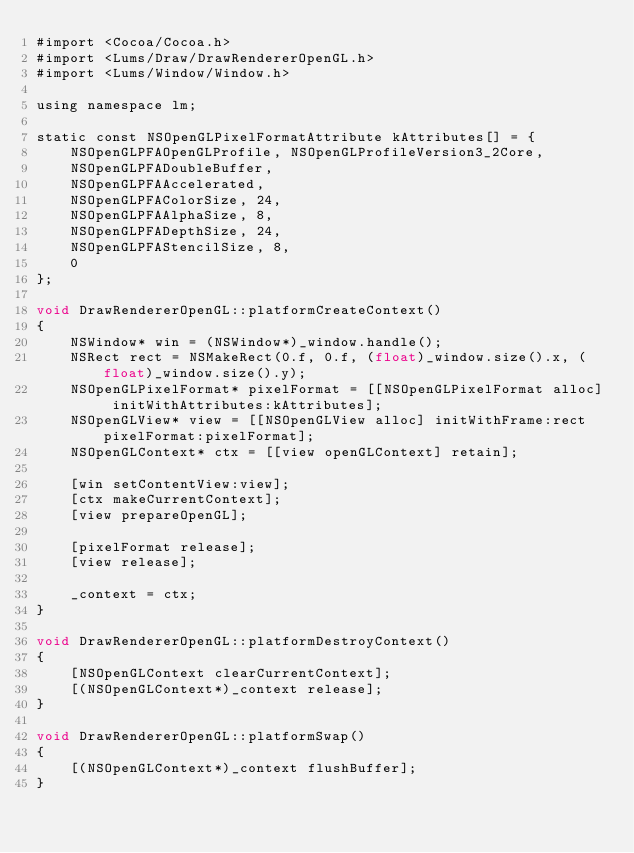<code> <loc_0><loc_0><loc_500><loc_500><_ObjectiveC_>#import <Cocoa/Cocoa.h>
#import <Lums/Draw/DrawRendererOpenGL.h>
#import <Lums/Window/Window.h>

using namespace lm;

static const NSOpenGLPixelFormatAttribute kAttributes[] = {
    NSOpenGLPFAOpenGLProfile, NSOpenGLProfileVersion3_2Core,
    NSOpenGLPFADoubleBuffer,
    NSOpenGLPFAAccelerated,
    NSOpenGLPFAColorSize, 24,
    NSOpenGLPFAAlphaSize, 8,
    NSOpenGLPFADepthSize, 24,
    NSOpenGLPFAStencilSize, 8,
    0
};

void DrawRendererOpenGL::platformCreateContext()
{
    NSWindow* win = (NSWindow*)_window.handle();
    NSRect rect = NSMakeRect(0.f, 0.f, (float)_window.size().x, (float)_window.size().y);
    NSOpenGLPixelFormat* pixelFormat = [[NSOpenGLPixelFormat alloc] initWithAttributes:kAttributes];
    NSOpenGLView* view = [[NSOpenGLView alloc] initWithFrame:rect pixelFormat:pixelFormat];
    NSOpenGLContext* ctx = [[view openGLContext] retain];

    [win setContentView:view];
    [ctx makeCurrentContext];
    [view prepareOpenGL];

    [pixelFormat release];
    [view release];

    _context = ctx;
}

void DrawRendererOpenGL::platformDestroyContext()
{
    [NSOpenGLContext clearCurrentContext];
    [(NSOpenGLContext*)_context release];
}

void DrawRendererOpenGL::platformSwap()
{
    [(NSOpenGLContext*)_context flushBuffer];
}
</code> 